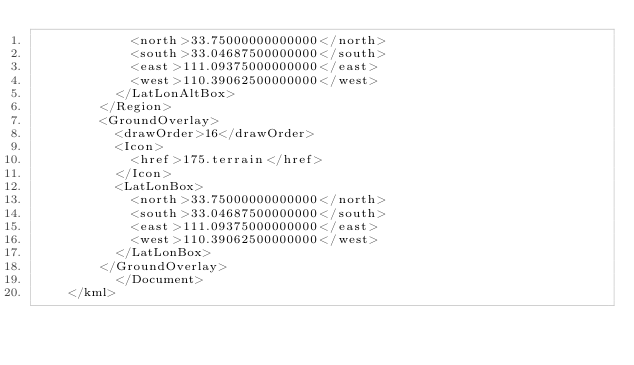Convert code to text. <code><loc_0><loc_0><loc_500><loc_500><_XML_>	        <north>33.75000000000000</north>
	        <south>33.04687500000000</south>
	        <east>111.09375000000000</east>
	        <west>110.39062500000000</west>
	      </LatLonAltBox>
	    </Region>
	    <GroundOverlay>
	      <drawOrder>16</drawOrder>
	      <Icon>
	        <href>175.terrain</href>
	      </Icon>
	      <LatLonBox>
	        <north>33.75000000000000</north>
	        <south>33.04687500000000</south>
	        <east>111.09375000000000</east>
	        <west>110.39062500000000</west>
	      </LatLonBox>
	    </GroundOverlay>
		  </Document>
	</kml>
	</code> 